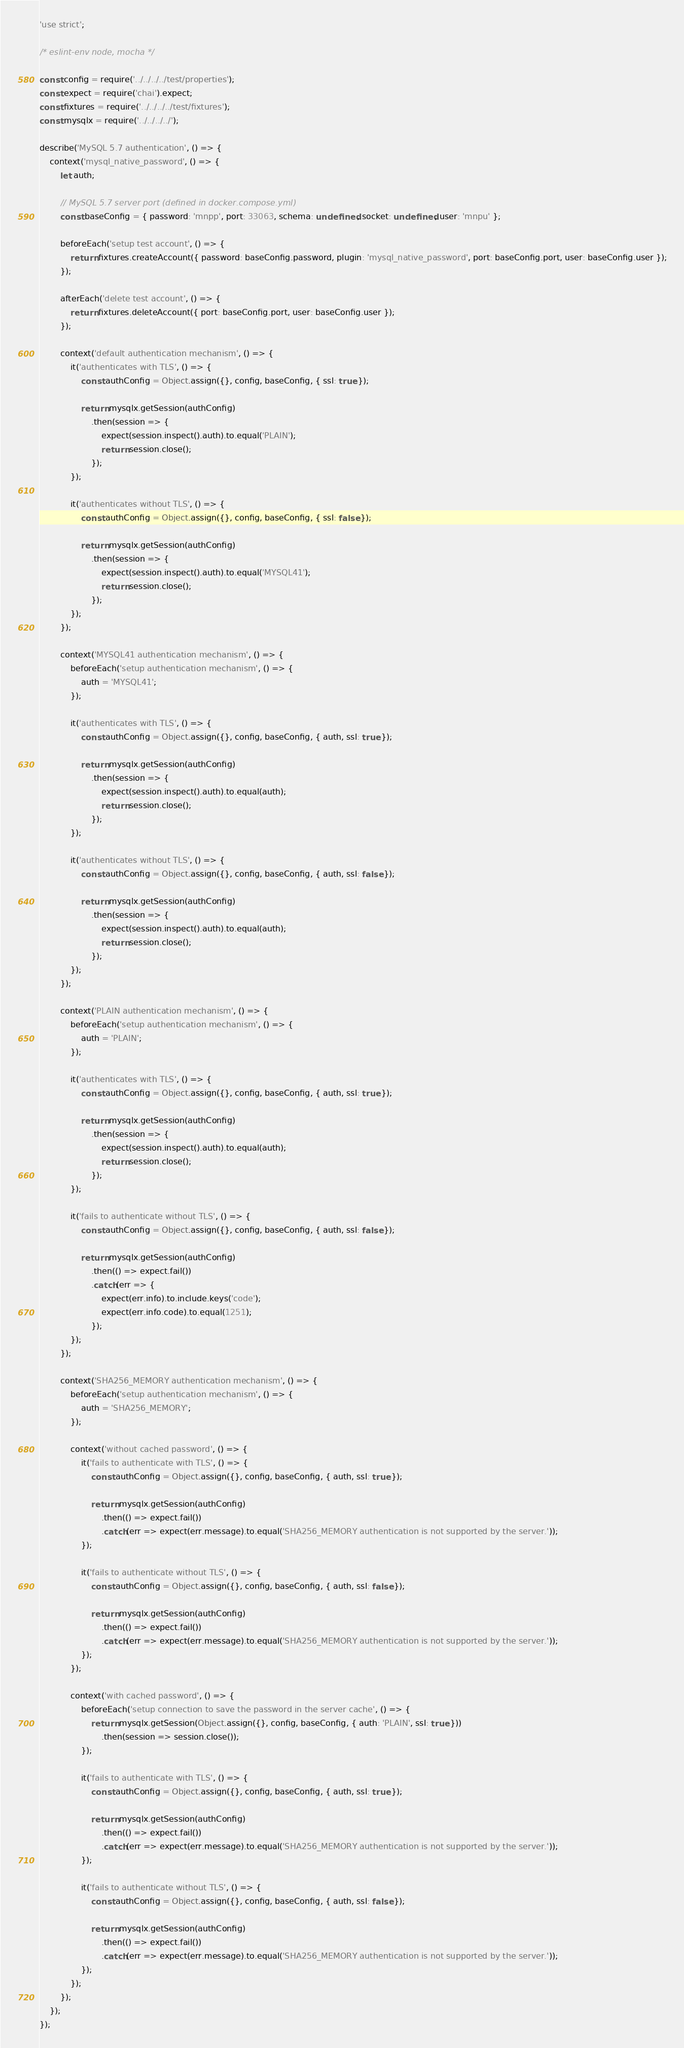Convert code to text. <code><loc_0><loc_0><loc_500><loc_500><_JavaScript_>'use strict';

/* eslint-env node, mocha */

const config = require('../../../../test/properties');
const expect = require('chai').expect;
const fixtures = require('../../../../test/fixtures');
const mysqlx = require('../../../../');

describe('MySQL 5.7 authentication', () => {
    context('mysql_native_password', () => {
        let auth;

        // MySQL 5.7 server port (defined in docker.compose.yml)
        const baseConfig = { password: 'mnpp', port: 33063, schema: undefined, socket: undefined, user: 'mnpu' };

        beforeEach('setup test account', () => {
            return fixtures.createAccount({ password: baseConfig.password, plugin: 'mysql_native_password', port: baseConfig.port, user: baseConfig.user });
        });

        afterEach('delete test account', () => {
            return fixtures.deleteAccount({ port: baseConfig.port, user: baseConfig.user });
        });

        context('default authentication mechanism', () => {
            it('authenticates with TLS', () => {
                const authConfig = Object.assign({}, config, baseConfig, { ssl: true });

                return mysqlx.getSession(authConfig)
                    .then(session => {
                        expect(session.inspect().auth).to.equal('PLAIN');
                        return session.close();
                    });
            });

            it('authenticates without TLS', () => {
                const authConfig = Object.assign({}, config, baseConfig, { ssl: false });

                return mysqlx.getSession(authConfig)
                    .then(session => {
                        expect(session.inspect().auth).to.equal('MYSQL41');
                        return session.close();
                    });
            });
        });

        context('MYSQL41 authentication mechanism', () => {
            beforeEach('setup authentication mechanism', () => {
                auth = 'MYSQL41';
            });

            it('authenticates with TLS', () => {
                const authConfig = Object.assign({}, config, baseConfig, { auth, ssl: true });

                return mysqlx.getSession(authConfig)
                    .then(session => {
                        expect(session.inspect().auth).to.equal(auth);
                        return session.close();
                    });
            });

            it('authenticates without TLS', () => {
                const authConfig = Object.assign({}, config, baseConfig, { auth, ssl: false });

                return mysqlx.getSession(authConfig)
                    .then(session => {
                        expect(session.inspect().auth).to.equal(auth);
                        return session.close();
                    });
            });
        });

        context('PLAIN authentication mechanism', () => {
            beforeEach('setup authentication mechanism', () => {
                auth = 'PLAIN';
            });

            it('authenticates with TLS', () => {
                const authConfig = Object.assign({}, config, baseConfig, { auth, ssl: true });

                return mysqlx.getSession(authConfig)
                    .then(session => {
                        expect(session.inspect().auth).to.equal(auth);
                        return session.close();
                    });
            });

            it('fails to authenticate without TLS', () => {
                const authConfig = Object.assign({}, config, baseConfig, { auth, ssl: false });

                return mysqlx.getSession(authConfig)
                    .then(() => expect.fail())
                    .catch(err => {
                        expect(err.info).to.include.keys('code');
                        expect(err.info.code).to.equal(1251);
                    });
            });
        });

        context('SHA256_MEMORY authentication mechanism', () => {
            beforeEach('setup authentication mechanism', () => {
                auth = 'SHA256_MEMORY';
            });

            context('without cached password', () => {
                it('fails to authenticate with TLS', () => {
                    const authConfig = Object.assign({}, config, baseConfig, { auth, ssl: true });

                    return mysqlx.getSession(authConfig)
                        .then(() => expect.fail())
                        .catch(err => expect(err.message).to.equal('SHA256_MEMORY authentication is not supported by the server.'));
                });

                it('fails to authenticate without TLS', () => {
                    const authConfig = Object.assign({}, config, baseConfig, { auth, ssl: false });

                    return mysqlx.getSession(authConfig)
                        .then(() => expect.fail())
                        .catch(err => expect(err.message).to.equal('SHA256_MEMORY authentication is not supported by the server.'));
                });
            });

            context('with cached password', () => {
                beforeEach('setup connection to save the password in the server cache', () => {
                    return mysqlx.getSession(Object.assign({}, config, baseConfig, { auth: 'PLAIN', ssl: true }))
                        .then(session => session.close());
                });

                it('fails to authenticate with TLS', () => {
                    const authConfig = Object.assign({}, config, baseConfig, { auth, ssl: true });

                    return mysqlx.getSession(authConfig)
                        .then(() => expect.fail())
                        .catch(err => expect(err.message).to.equal('SHA256_MEMORY authentication is not supported by the server.'));
                });

                it('fails to authenticate without TLS', () => {
                    const authConfig = Object.assign({}, config, baseConfig, { auth, ssl: false });

                    return mysqlx.getSession(authConfig)
                        .then(() => expect.fail())
                        .catch(err => expect(err.message).to.equal('SHA256_MEMORY authentication is not supported by the server.'));
                });
            });
        });
    });
});
</code> 